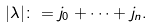Convert formula to latex. <formula><loc_0><loc_0><loc_500><loc_500>| \lambda | \colon = j _ { 0 } + \dots + j _ { n } .</formula> 